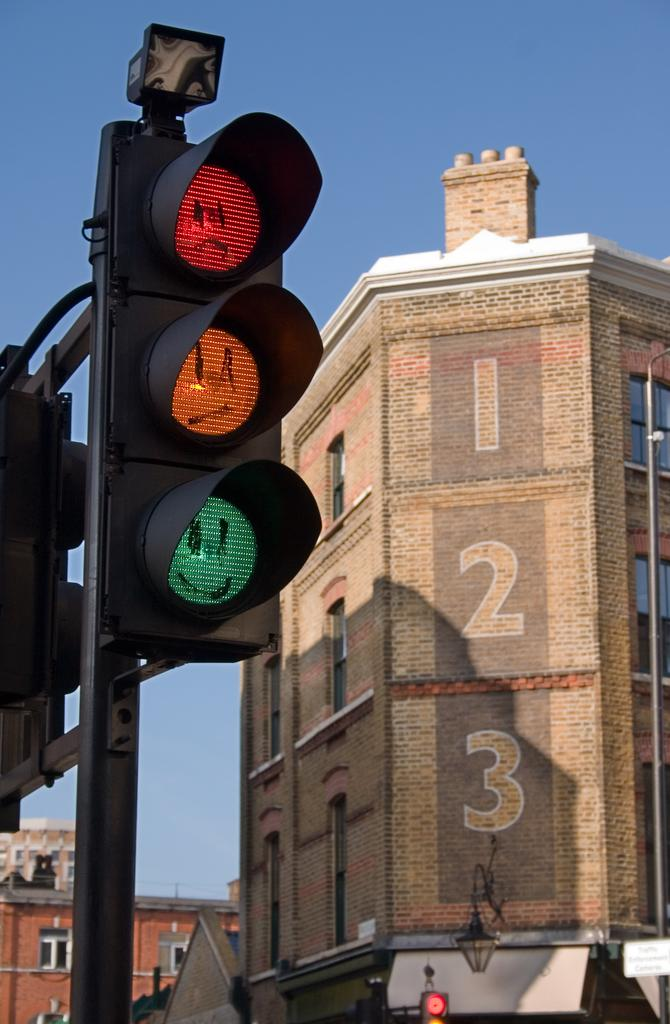<image>
Give a short and clear explanation of the subsequent image. A traffic light in front of a building with 1 2 3 painted on it. 